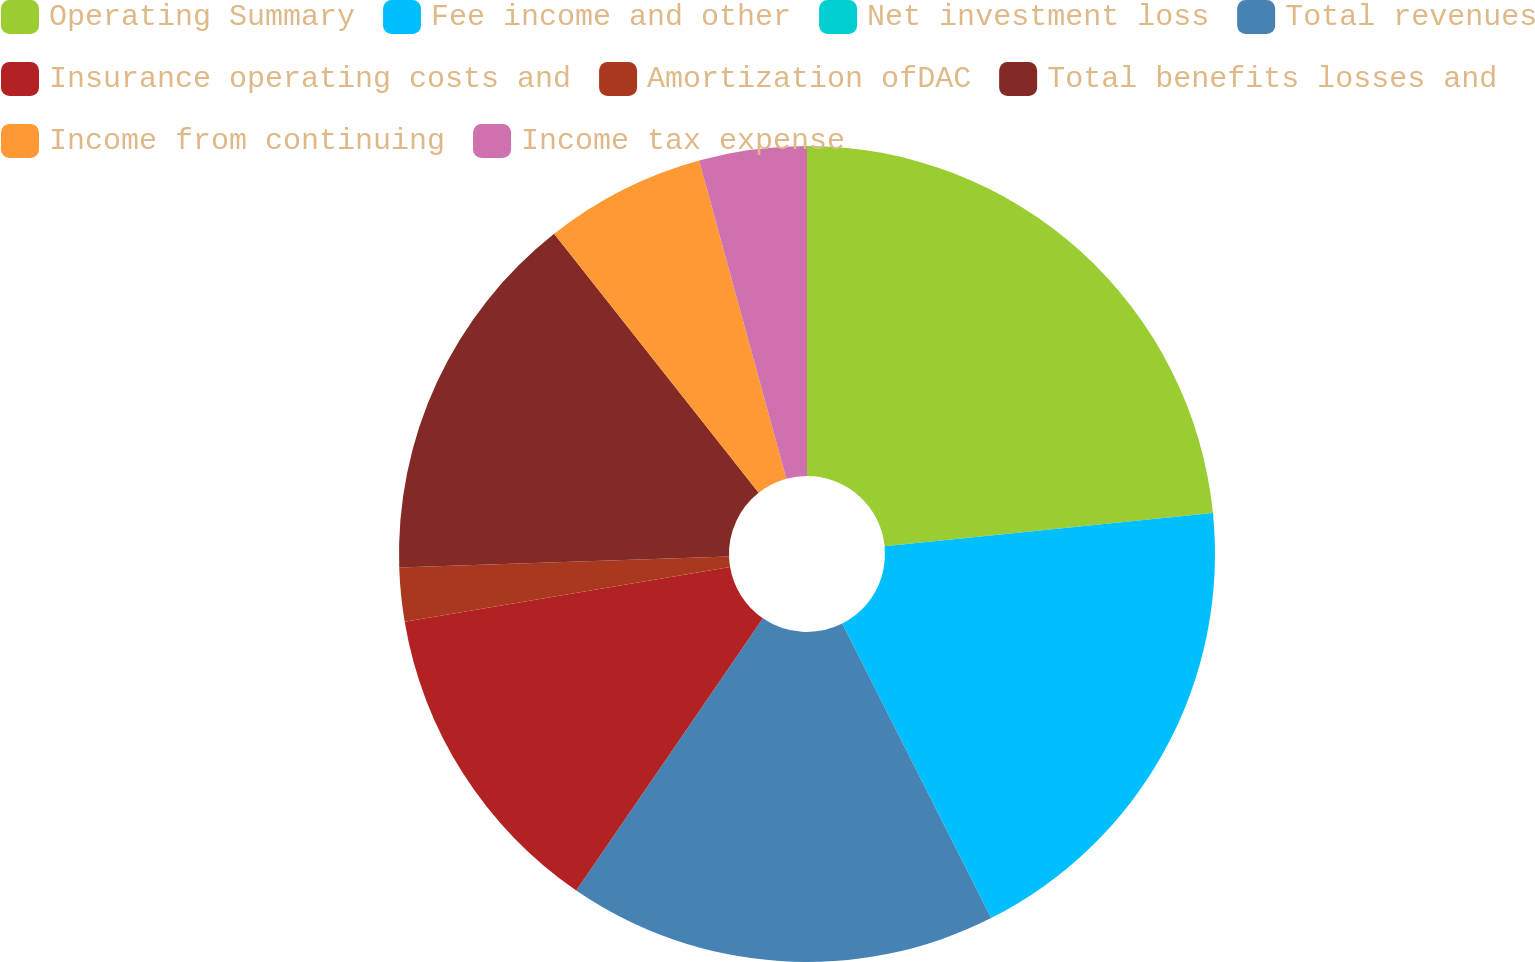Convert chart to OTSL. <chart><loc_0><loc_0><loc_500><loc_500><pie_chart><fcel>Operating Summary<fcel>Fee income and other<fcel>Net investment loss<fcel>Total revenues<fcel>Insurance operating costs and<fcel>Amortization ofDAC<fcel>Total benefits losses and<fcel>Income from continuing<fcel>Income tax expense<nl><fcel>23.4%<fcel>19.15%<fcel>0.0%<fcel>17.02%<fcel>12.77%<fcel>2.13%<fcel>14.89%<fcel>6.38%<fcel>4.26%<nl></chart> 